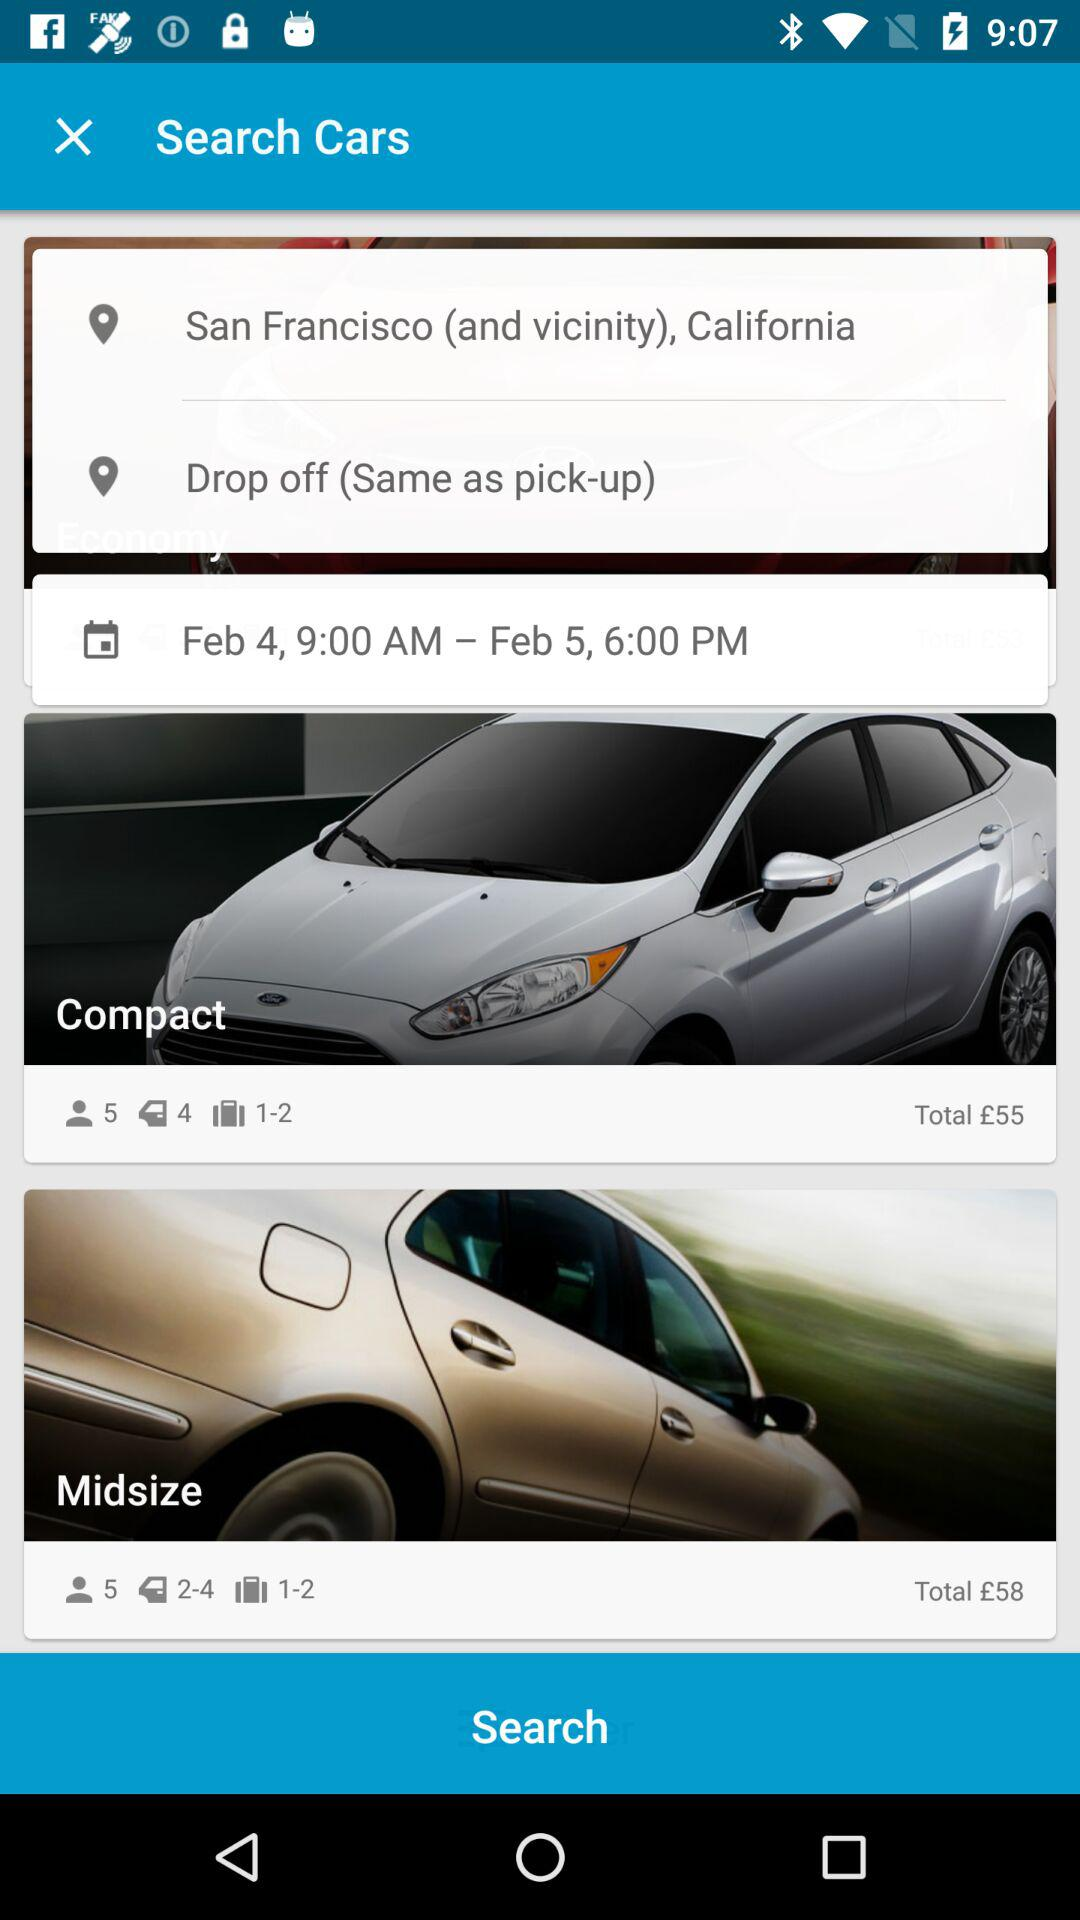What is the destination location? The destination location is Drop-off (same as Pick-up). 